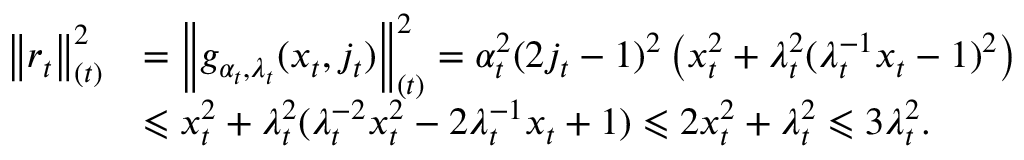Convert formula to latex. <formula><loc_0><loc_0><loc_500><loc_500>\begin{array} { r l } { \left \| r _ { t } \right \| _ { ( t ) } ^ { 2 } } & { = \left \| g _ { \alpha _ { t } , \lambda _ { t } } ( x _ { t } , j _ { t } ) \right \| _ { ( t ) } ^ { 2 } = \alpha _ { t } ^ { 2 } ( 2 j _ { t } - 1 ) ^ { 2 } \left ( x _ { t } ^ { 2 } + \lambda _ { t } ^ { 2 } ( \lambda _ { t } ^ { - 1 } x _ { t } - 1 ) ^ { 2 } \right ) } \\ & { \leqslant x _ { t } ^ { 2 } + \lambda _ { t } ^ { 2 } ( \lambda _ { t } ^ { - 2 } x _ { t } ^ { 2 } - 2 \lambda _ { t } ^ { - 1 } x _ { t } + 1 ) \leqslant 2 x _ { t } ^ { 2 } + \lambda _ { t } ^ { 2 } \leqslant 3 \lambda _ { t } ^ { 2 } . } \end{array}</formula> 